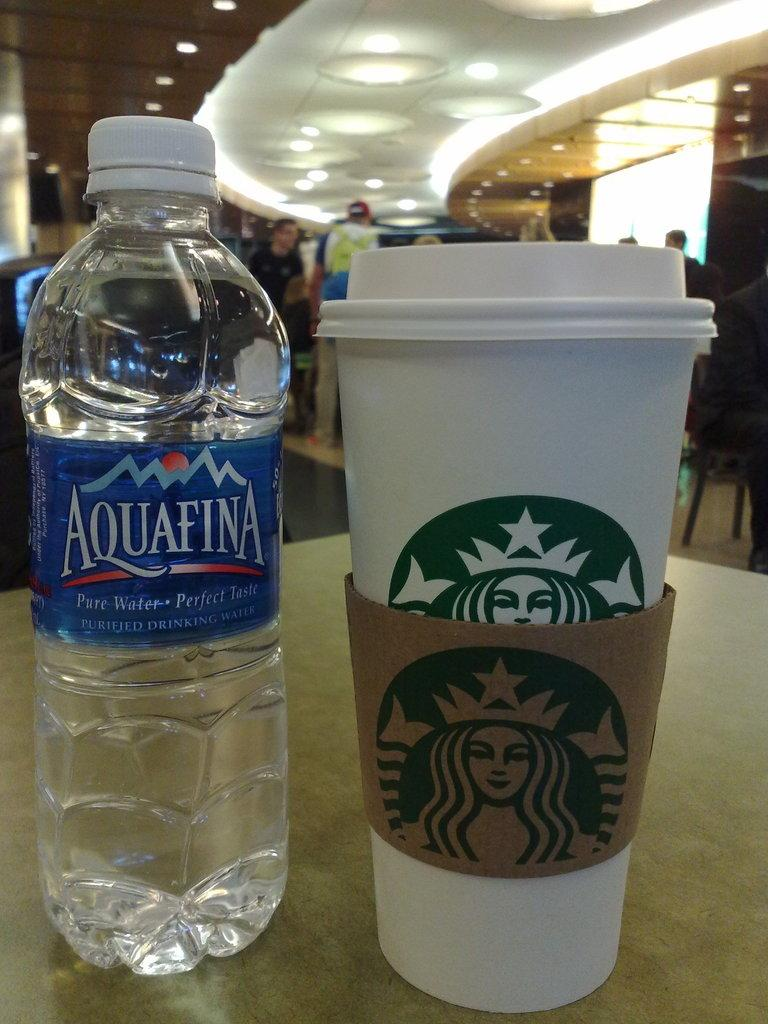<image>
Describe the image concisely. A full Aquafina water bottle next to a Starbucks coffee cup with a lid and cardboard holder. 